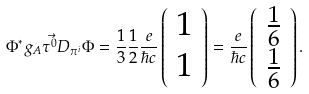Convert formula to latex. <formula><loc_0><loc_0><loc_500><loc_500>\Phi ^ { * } g _ { A } \vec { \tau ^ { 0 } } D _ { \pi ^ { i } } \Phi = \frac { 1 } { 3 } \frac { 1 } { 2 } \frac { e } { \hbar { c } } \left ( \begin{array} { r } 1 \\ 1 \end{array} \right ) = \frac { e } { \hbar { c } } \left ( \begin{array} { r } \frac { 1 } { 6 } \\ \frac { 1 } { 6 } \end{array} \right ) .</formula> 